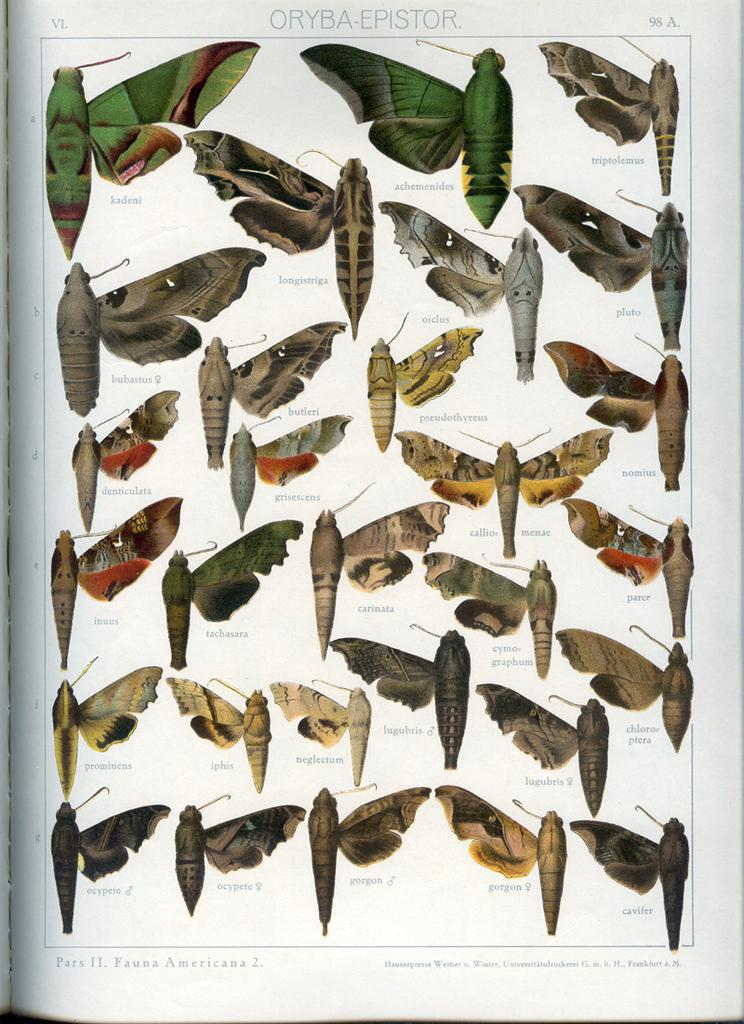What is the medium of the image? The image is on a paper. What type of creatures can be seen in the image? There are insects in the image. Is there any written content in the image? Yes, there is text in the image. What type of scarf is being used to cover the insects in the image? There is no scarf present in the image, and the insects are not covered. 